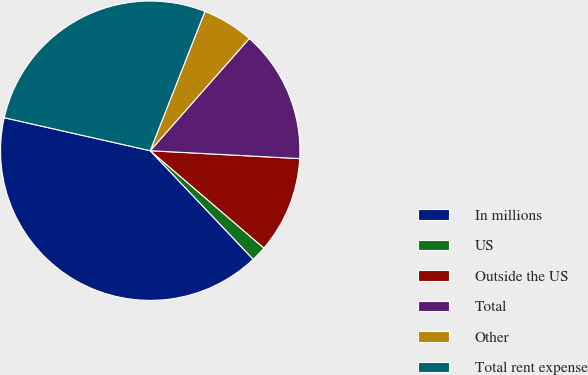Convert chart to OTSL. <chart><loc_0><loc_0><loc_500><loc_500><pie_chart><fcel>In millions<fcel>US<fcel>Outside the US<fcel>Total<fcel>Other<fcel>Total rent expense<nl><fcel>40.62%<fcel>1.65%<fcel>10.43%<fcel>14.33%<fcel>5.55%<fcel>27.42%<nl></chart> 